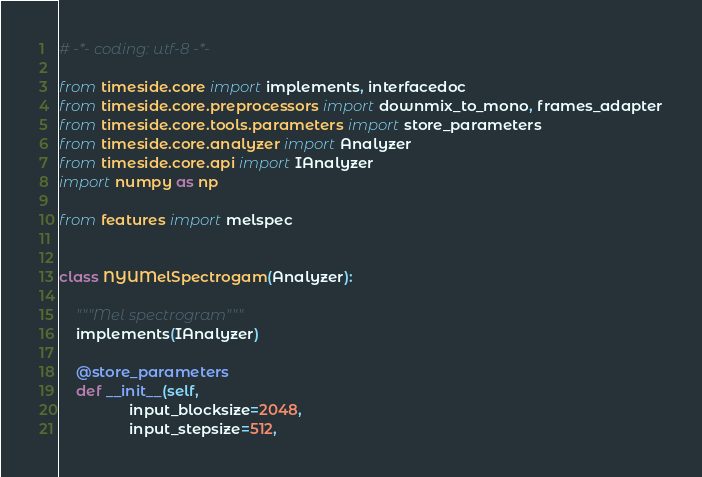Convert code to text. <code><loc_0><loc_0><loc_500><loc_500><_Python_># -*- coding: utf-8 -*-

from timeside.core import implements, interfacedoc
from timeside.core.preprocessors import downmix_to_mono, frames_adapter
from timeside.core.tools.parameters import store_parameters
from timeside.core.analyzer import Analyzer
from timeside.core.api import IAnalyzer
import numpy as np

from features import melspec


class NYUMelSpectrogam(Analyzer):

    """Mel spectrogram"""
    implements(IAnalyzer)

    @store_parameters
    def __init__(self,
                 input_blocksize=2048,
                 input_stepsize=512,</code> 